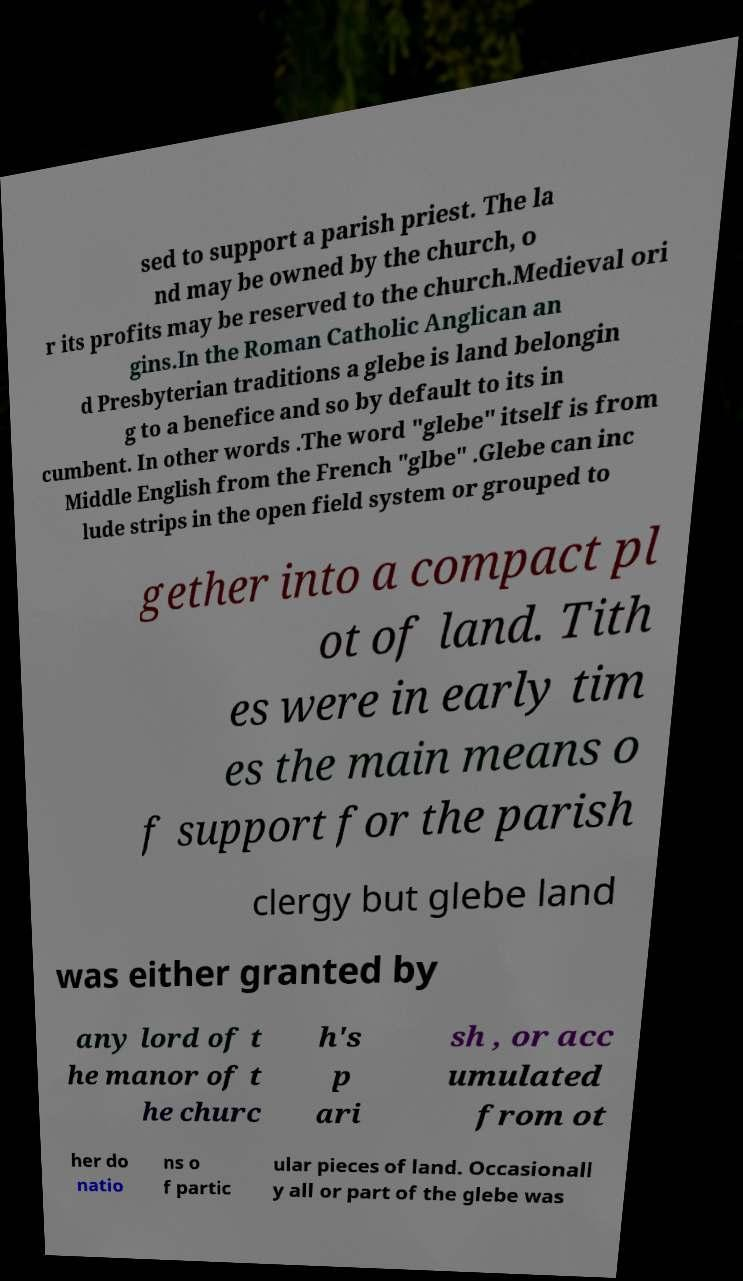Can you read and provide the text displayed in the image?This photo seems to have some interesting text. Can you extract and type it out for me? sed to support a parish priest. The la nd may be owned by the church, o r its profits may be reserved to the church.Medieval ori gins.In the Roman Catholic Anglican an d Presbyterian traditions a glebe is land belongin g to a benefice and so by default to its in cumbent. In other words .The word "glebe" itself is from Middle English from the French "glbe" .Glebe can inc lude strips in the open field system or grouped to gether into a compact pl ot of land. Tith es were in early tim es the main means o f support for the parish clergy but glebe land was either granted by any lord of t he manor of t he churc h's p ari sh , or acc umulated from ot her do natio ns o f partic ular pieces of land. Occasionall y all or part of the glebe was 